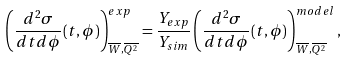Convert formula to latex. <formula><loc_0><loc_0><loc_500><loc_500>\left ( \frac { d ^ { 2 } \sigma } { d t d \phi } ( t , \phi ) \right ) ^ { e x p } _ { \overline { W } , \overline { Q ^ { 2 } } } = \frac { Y _ { e x p } } { Y _ { s i m } } \left ( \frac { d ^ { 2 } \sigma } { d t d \phi } ( t , \phi ) \right ) ^ { m o d e l } _ { \overline { W } , \overline { Q ^ { 2 } } } ,</formula> 